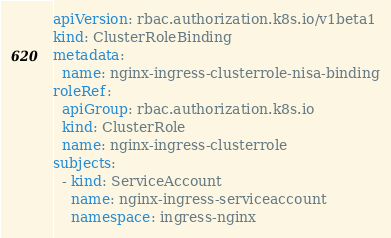<code> <loc_0><loc_0><loc_500><loc_500><_YAML_>apiVersion: rbac.authorization.k8s.io/v1beta1
kind: ClusterRoleBinding
metadata:
  name: nginx-ingress-clusterrole-nisa-binding
roleRef:
  apiGroup: rbac.authorization.k8s.io
  kind: ClusterRole
  name: nginx-ingress-clusterrole
subjects:
  - kind: ServiceAccount
    name: nginx-ingress-serviceaccount
    namespace: ingress-nginx</code> 